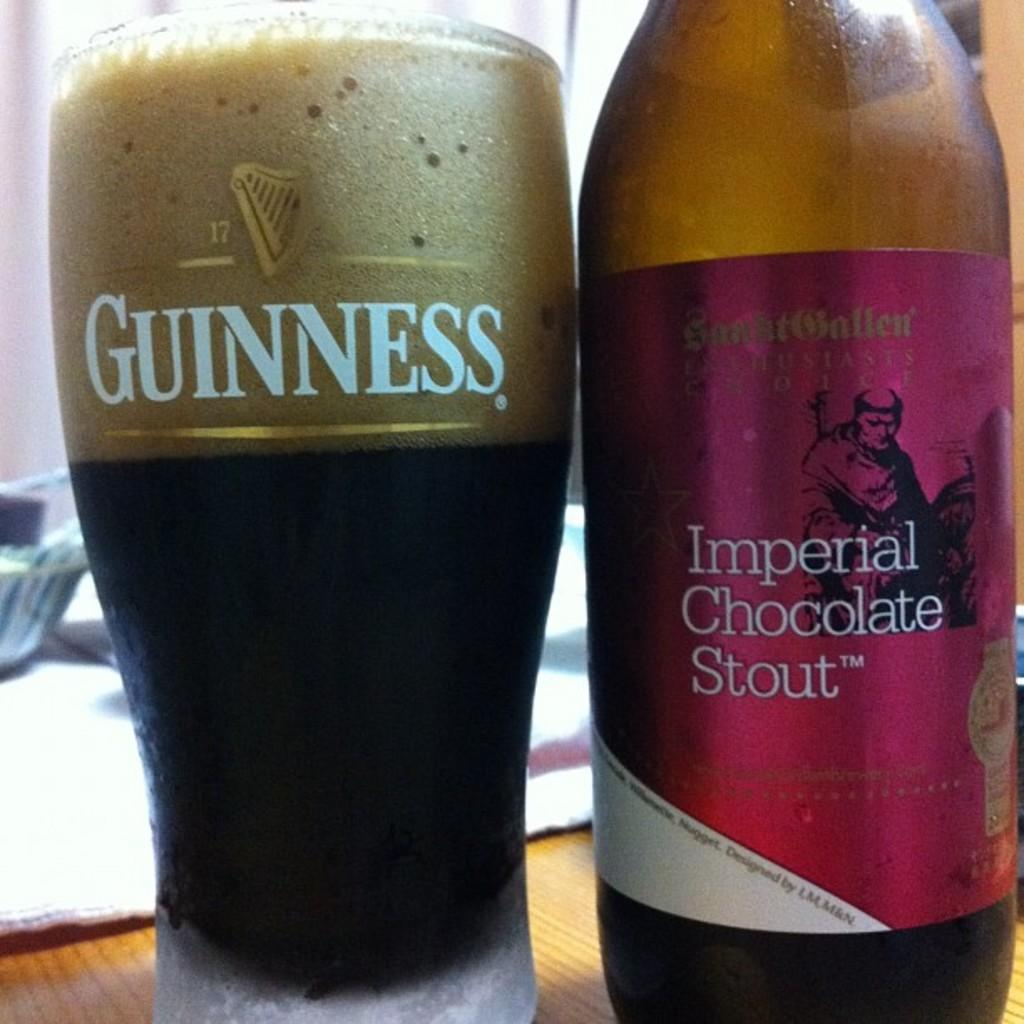<image>
Share a concise interpretation of the image provided. An opened bottle of Imperial Chocolate Stout next to a full Guinness glass. 